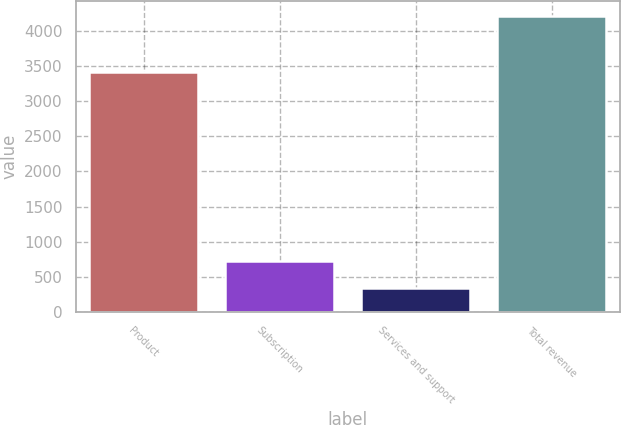Convert chart. <chart><loc_0><loc_0><loc_500><loc_500><bar_chart><fcel>Product<fcel>Subscription<fcel>Services and support<fcel>Total revenue<nl><fcel>3416.5<fcel>728.71<fcel>341.2<fcel>4216.3<nl></chart> 